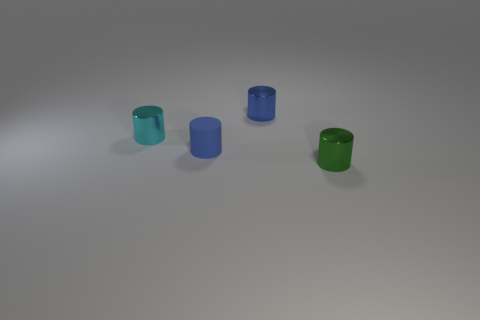Are there any small shiny things of the same color as the small matte object?
Offer a terse response. Yes. How many other objects are the same size as the cyan cylinder?
Keep it short and to the point. 3. What material is the blue object that is on the left side of the blue cylinder behind the small metal thing left of the small blue rubber cylinder?
Provide a short and direct response. Rubber. How many spheres are small cyan metallic objects or small blue things?
Offer a terse response. 0. Is the number of tiny blue cylinders behind the tiny rubber cylinder greater than the number of blue metal objects in front of the green thing?
Provide a succinct answer. Yes. What number of small cyan objects are behind the small blue cylinder in front of the cyan cylinder?
Provide a succinct answer. 1. What number of things are either gray matte balls or tiny blue rubber things?
Offer a terse response. 1. Is the tiny cyan metal thing the same shape as the blue matte object?
Make the answer very short. Yes. What material is the green thing?
Offer a terse response. Metal. How many tiny things are both behind the tiny green metal cylinder and in front of the cyan cylinder?
Keep it short and to the point. 1. 